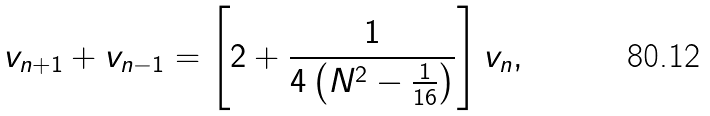<formula> <loc_0><loc_0><loc_500><loc_500>v _ { n + 1 } + v _ { n - 1 } = \left [ 2 + \frac { 1 } { 4 \left ( N ^ { 2 } - \frac { 1 } { 1 6 } \right ) } \right ] v _ { n } ,</formula> 